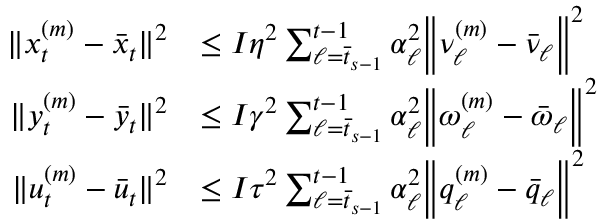Convert formula to latex. <formula><loc_0><loc_0><loc_500><loc_500>\begin{array} { r l } { \| x _ { t } ^ { ( m ) } - \bar { x } _ { t } \| ^ { 2 } } & { \leq I \eta ^ { 2 } \sum _ { \ell = \bar { t } _ { s - 1 } } ^ { t - 1 } \alpha _ { \ell } ^ { 2 } \left \| \nu _ { \ell } ^ { ( m ) } - \bar { \nu } _ { \ell } \right \| ^ { 2 } } \\ { \| y _ { t } ^ { ( m ) } - \bar { y } _ { t } \| ^ { 2 } } & { \leq I \gamma ^ { 2 } \sum _ { \ell = \bar { t } _ { s - 1 } } ^ { t - 1 } \alpha _ { \ell } ^ { 2 } \left \| \omega _ { \ell } ^ { ( m ) } - \bar { \omega } _ { \ell } \right \| ^ { 2 } } \\ { \| u _ { t } ^ { ( m ) } - \bar { u } _ { t } \| ^ { 2 } } & { \leq I \tau ^ { 2 } \sum _ { \ell = \bar { t } _ { s - 1 } } ^ { t - 1 } \alpha _ { \ell } ^ { 2 } \left \| q _ { \ell } ^ { ( m ) } - \bar { q } _ { \ell } \right \| ^ { 2 } } \end{array}</formula> 